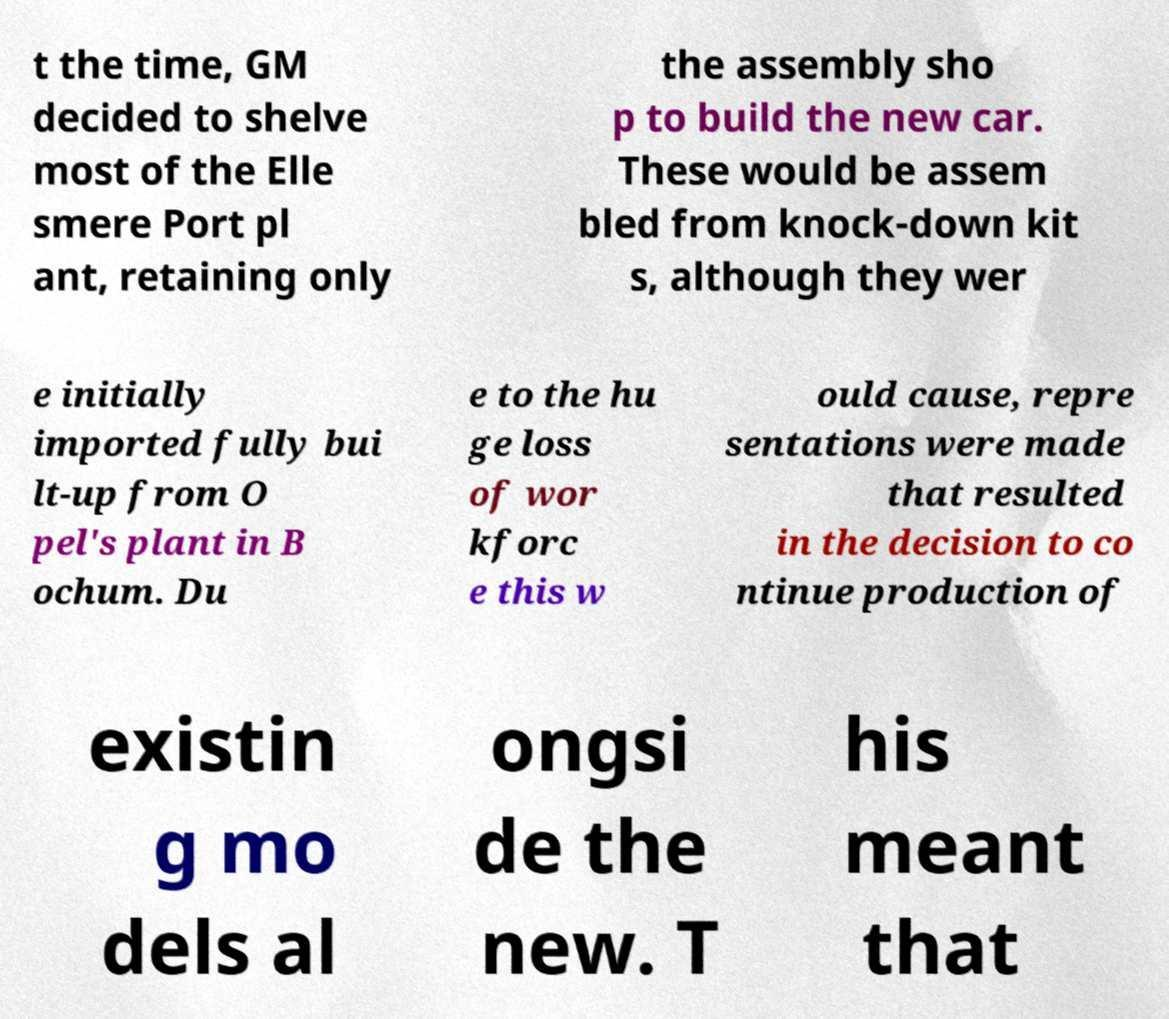Please identify and transcribe the text found in this image. t the time, GM decided to shelve most of the Elle smere Port pl ant, retaining only the assembly sho p to build the new car. These would be assem bled from knock-down kit s, although they wer e initially imported fully bui lt-up from O pel's plant in B ochum. Du e to the hu ge loss of wor kforc e this w ould cause, repre sentations were made that resulted in the decision to co ntinue production of existin g mo dels al ongsi de the new. T his meant that 